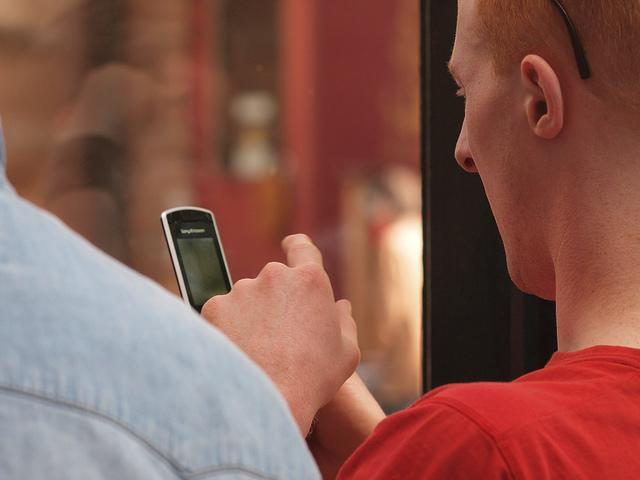The bald man with glasses is using what kind of phone? flip phone 